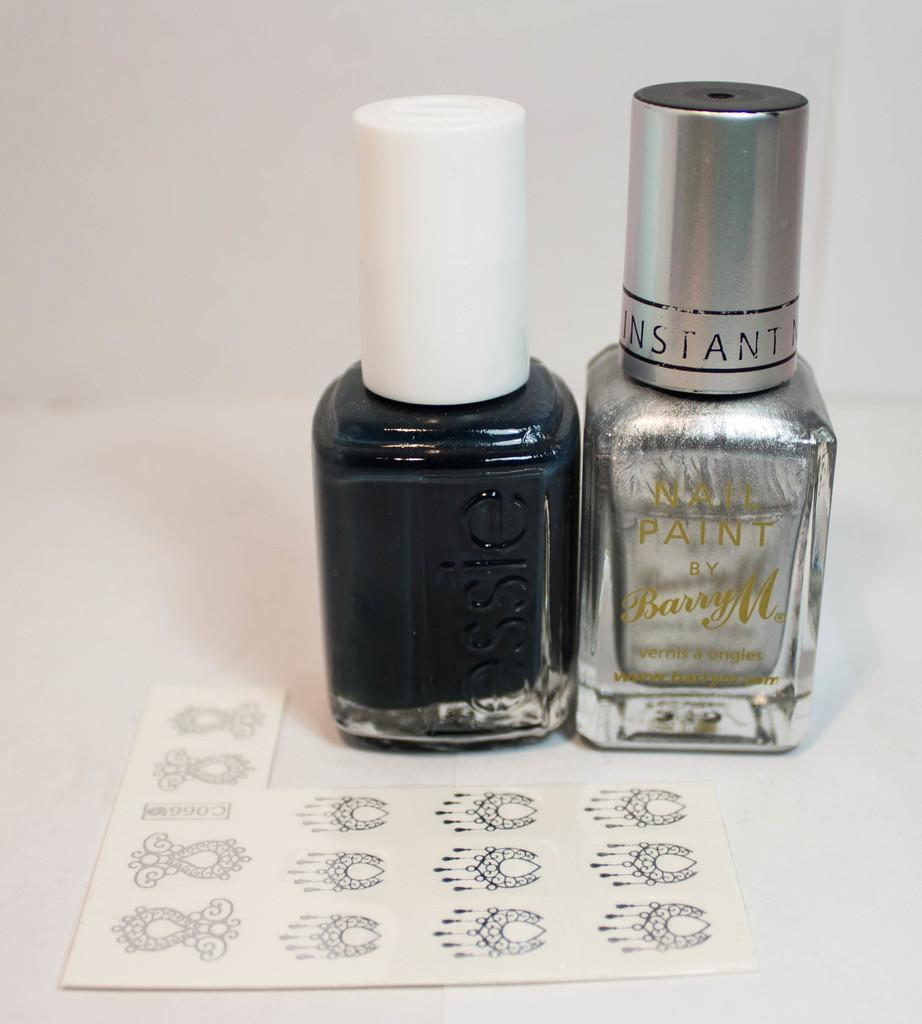What objects are present in the image related to nail care? There are two nail paint bottles in the image. Can you describe the appearance of the nail paint bottles? The appearance of the nail paint bottles is not mentioned in the provided facts, so we cannot describe them. What might be the purpose of having two nail paint bottles in the image? The purpose of having two nail paint bottles in the image is not mentioned in the provided facts, so we cannot determine their purpose. What type of oven is visible in the image? There is no oven present in the image; it only contains two nail paint bottles. 